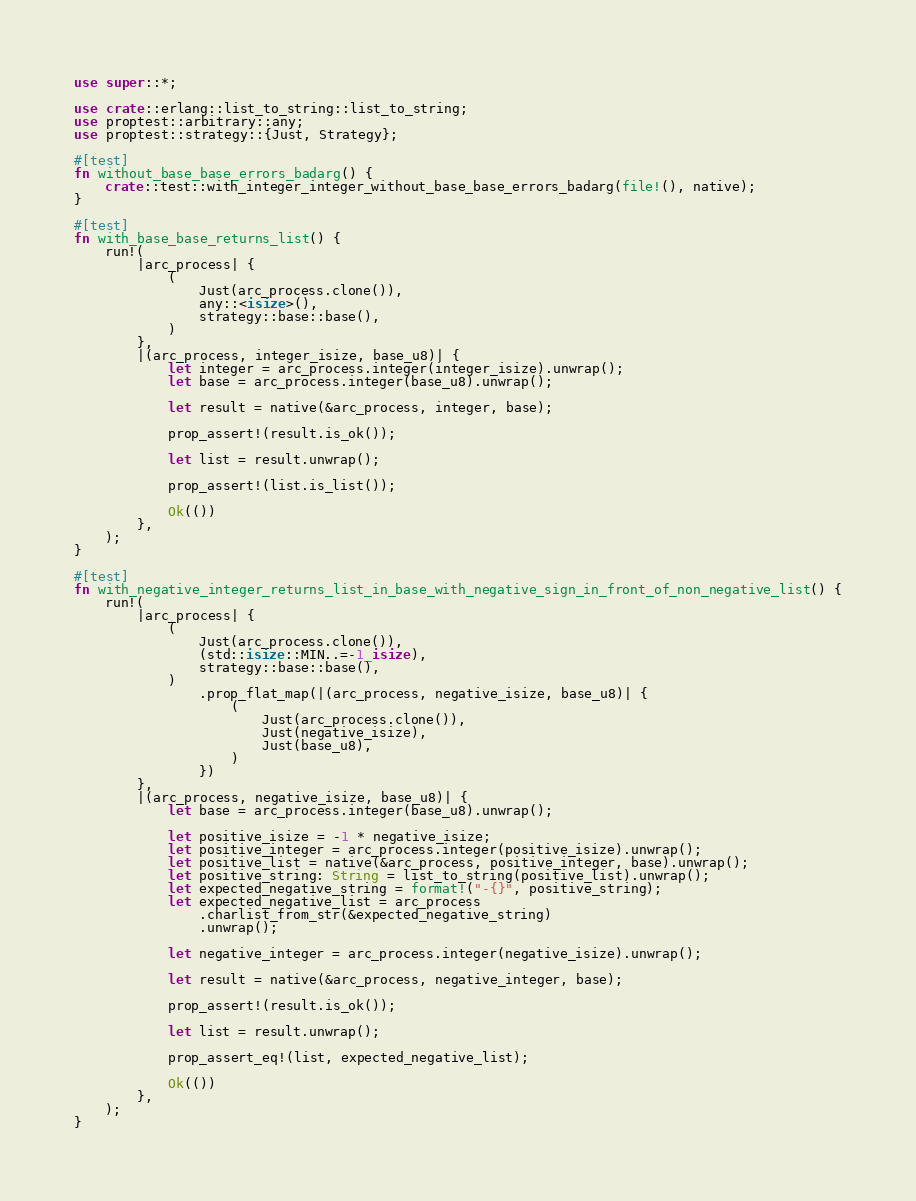Convert code to text. <code><loc_0><loc_0><loc_500><loc_500><_Rust_>use super::*;

use crate::erlang::list_to_string::list_to_string;
use proptest::arbitrary::any;
use proptest::strategy::{Just, Strategy};

#[test]
fn without_base_base_errors_badarg() {
    crate::test::with_integer_integer_without_base_base_errors_badarg(file!(), native);
}

#[test]
fn with_base_base_returns_list() {
    run!(
        |arc_process| {
            (
                Just(arc_process.clone()),
                any::<isize>(),
                strategy::base::base(),
            )
        },
        |(arc_process, integer_isize, base_u8)| {
            let integer = arc_process.integer(integer_isize).unwrap();
            let base = arc_process.integer(base_u8).unwrap();

            let result = native(&arc_process, integer, base);

            prop_assert!(result.is_ok());

            let list = result.unwrap();

            prop_assert!(list.is_list());

            Ok(())
        },
    );
}

#[test]
fn with_negative_integer_returns_list_in_base_with_negative_sign_in_front_of_non_negative_list() {
    run!(
        |arc_process| {
            (
                Just(arc_process.clone()),
                (std::isize::MIN..=-1_isize),
                strategy::base::base(),
            )
                .prop_flat_map(|(arc_process, negative_isize, base_u8)| {
                    (
                        Just(arc_process.clone()),
                        Just(negative_isize),
                        Just(base_u8),
                    )
                })
        },
        |(arc_process, negative_isize, base_u8)| {
            let base = arc_process.integer(base_u8).unwrap();

            let positive_isize = -1 * negative_isize;
            let positive_integer = arc_process.integer(positive_isize).unwrap();
            let positive_list = native(&arc_process, positive_integer, base).unwrap();
            let positive_string: String = list_to_string(positive_list).unwrap();
            let expected_negative_string = format!("-{}", positive_string);
            let expected_negative_list = arc_process
                .charlist_from_str(&expected_negative_string)
                .unwrap();

            let negative_integer = arc_process.integer(negative_isize).unwrap();

            let result = native(&arc_process, negative_integer, base);

            prop_assert!(result.is_ok());

            let list = result.unwrap();

            prop_assert_eq!(list, expected_negative_list);

            Ok(())
        },
    );
}
</code> 